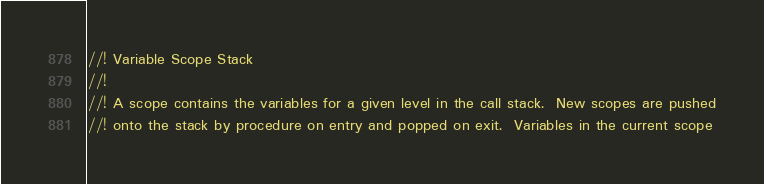<code> <loc_0><loc_0><loc_500><loc_500><_Rust_>//! Variable Scope Stack
//!
//! A scope contains the variables for a given level in the call stack.  New scopes are pushed
//! onto the stack by procedure on entry and popped on exit.  Variables in the current scope</code> 